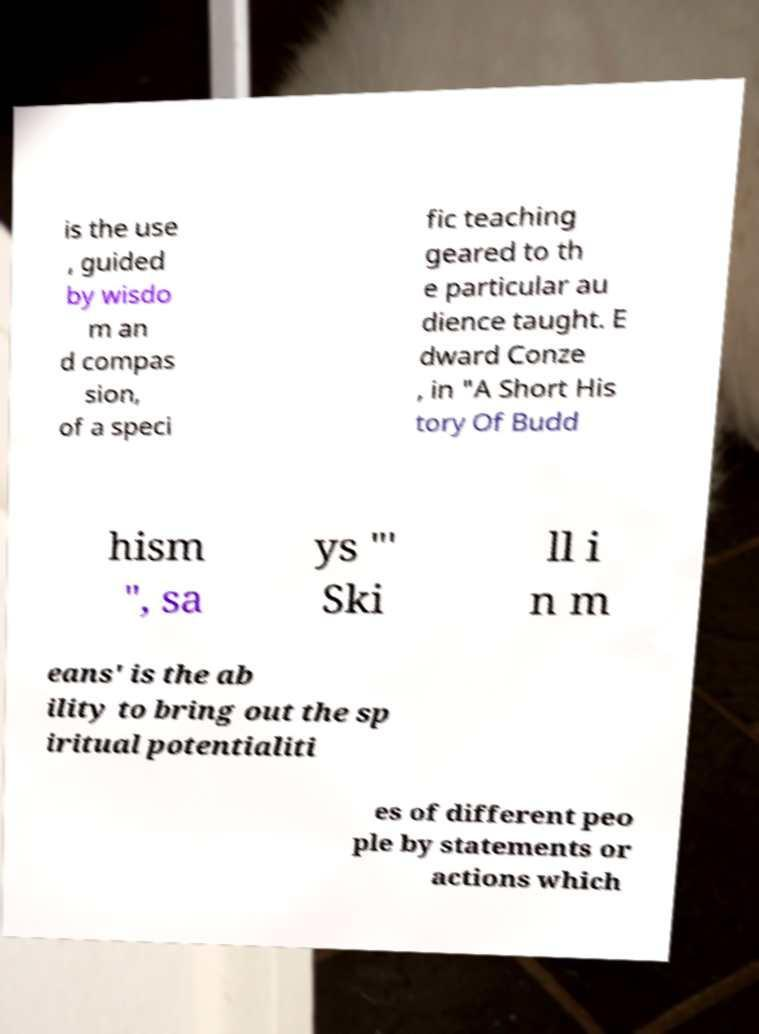For documentation purposes, I need the text within this image transcribed. Could you provide that? is the use , guided by wisdo m an d compas sion, of a speci fic teaching geared to th e particular au dience taught. E dward Conze , in "A Short His tory Of Budd hism ", sa ys "' Ski ll i n m eans' is the ab ility to bring out the sp iritual potentialiti es of different peo ple by statements or actions which 